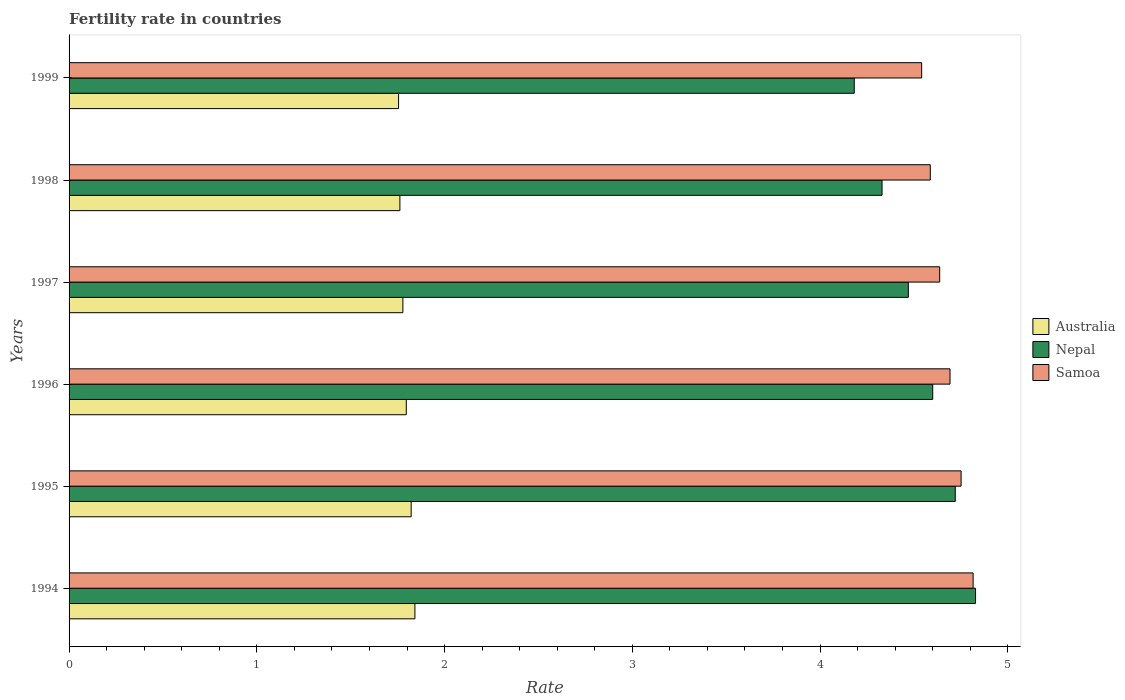How many different coloured bars are there?
Make the answer very short. 3. How many groups of bars are there?
Keep it short and to the point. 6. Are the number of bars per tick equal to the number of legend labels?
Make the answer very short. Yes. In how many cases, is the number of bars for a given year not equal to the number of legend labels?
Your response must be concise. 0. What is the fertility rate in Nepal in 1999?
Give a very brief answer. 4.18. Across all years, what is the maximum fertility rate in Samoa?
Offer a very short reply. 4.82. Across all years, what is the minimum fertility rate in Samoa?
Offer a very short reply. 4.54. What is the total fertility rate in Australia in the graph?
Your response must be concise. 10.75. What is the difference between the fertility rate in Samoa in 1994 and that in 1997?
Your answer should be very brief. 0.18. What is the difference between the fertility rate in Australia in 1994 and the fertility rate in Samoa in 1997?
Your answer should be very brief. -2.79. What is the average fertility rate in Australia per year?
Make the answer very short. 1.79. In the year 1995, what is the difference between the fertility rate in Nepal and fertility rate in Australia?
Offer a very short reply. 2.9. In how many years, is the fertility rate in Australia greater than 4 ?
Give a very brief answer. 0. What is the ratio of the fertility rate in Nepal in 1994 to that in 1998?
Make the answer very short. 1.12. Is the fertility rate in Australia in 1996 less than that in 1999?
Your response must be concise. No. What is the difference between the highest and the second highest fertility rate in Australia?
Provide a succinct answer. 0.02. What is the difference between the highest and the lowest fertility rate in Nepal?
Your answer should be compact. 0.65. In how many years, is the fertility rate in Samoa greater than the average fertility rate in Samoa taken over all years?
Keep it short and to the point. 3. Is the sum of the fertility rate in Australia in 1995 and 1997 greater than the maximum fertility rate in Samoa across all years?
Offer a very short reply. No. What does the 2nd bar from the top in 1999 represents?
Provide a short and direct response. Nepal. What does the 3rd bar from the bottom in 1994 represents?
Offer a very short reply. Samoa. Is it the case that in every year, the sum of the fertility rate in Samoa and fertility rate in Australia is greater than the fertility rate in Nepal?
Offer a terse response. Yes. How many years are there in the graph?
Provide a succinct answer. 6. Are the values on the major ticks of X-axis written in scientific E-notation?
Provide a short and direct response. No. Where does the legend appear in the graph?
Your answer should be very brief. Center right. How are the legend labels stacked?
Ensure brevity in your answer.  Vertical. What is the title of the graph?
Provide a short and direct response. Fertility rate in countries. Does "Lao PDR" appear as one of the legend labels in the graph?
Your answer should be very brief. No. What is the label or title of the X-axis?
Provide a short and direct response. Rate. What is the Rate of Australia in 1994?
Your answer should be very brief. 1.84. What is the Rate in Nepal in 1994?
Your answer should be compact. 4.83. What is the Rate in Samoa in 1994?
Make the answer very short. 4.82. What is the Rate of Australia in 1995?
Your response must be concise. 1.82. What is the Rate in Nepal in 1995?
Your answer should be very brief. 4.72. What is the Rate in Samoa in 1995?
Your answer should be compact. 4.75. What is the Rate of Australia in 1996?
Your response must be concise. 1.8. What is the Rate of Samoa in 1996?
Ensure brevity in your answer.  4.69. What is the Rate in Australia in 1997?
Offer a terse response. 1.78. What is the Rate of Nepal in 1997?
Your answer should be very brief. 4.47. What is the Rate of Samoa in 1997?
Offer a very short reply. 4.64. What is the Rate of Australia in 1998?
Give a very brief answer. 1.76. What is the Rate in Nepal in 1998?
Provide a succinct answer. 4.33. What is the Rate in Samoa in 1998?
Ensure brevity in your answer.  4.59. What is the Rate in Australia in 1999?
Make the answer very short. 1.75. What is the Rate of Nepal in 1999?
Provide a succinct answer. 4.18. What is the Rate in Samoa in 1999?
Your response must be concise. 4.54. Across all years, what is the maximum Rate of Australia?
Make the answer very short. 1.84. Across all years, what is the maximum Rate of Nepal?
Keep it short and to the point. 4.83. Across all years, what is the maximum Rate of Samoa?
Keep it short and to the point. 4.82. Across all years, what is the minimum Rate of Australia?
Make the answer very short. 1.75. Across all years, what is the minimum Rate in Nepal?
Give a very brief answer. 4.18. Across all years, what is the minimum Rate of Samoa?
Ensure brevity in your answer.  4.54. What is the total Rate of Australia in the graph?
Keep it short and to the point. 10.76. What is the total Rate of Nepal in the graph?
Provide a short and direct response. 27.13. What is the total Rate of Samoa in the graph?
Provide a short and direct response. 28.02. What is the difference between the Rate of Nepal in 1994 and that in 1995?
Provide a succinct answer. 0.11. What is the difference between the Rate in Samoa in 1994 and that in 1995?
Your answer should be very brief. 0.06. What is the difference between the Rate of Australia in 1994 and that in 1996?
Provide a short and direct response. 0.05. What is the difference between the Rate of Nepal in 1994 and that in 1996?
Provide a succinct answer. 0.23. What is the difference between the Rate in Samoa in 1994 and that in 1996?
Your answer should be very brief. 0.12. What is the difference between the Rate of Australia in 1994 and that in 1997?
Provide a short and direct response. 0.06. What is the difference between the Rate of Nepal in 1994 and that in 1997?
Keep it short and to the point. 0.36. What is the difference between the Rate of Samoa in 1994 and that in 1997?
Provide a succinct answer. 0.18. What is the difference between the Rate in Australia in 1994 and that in 1998?
Make the answer very short. 0.08. What is the difference between the Rate of Nepal in 1994 and that in 1998?
Offer a terse response. 0.5. What is the difference between the Rate of Samoa in 1994 and that in 1998?
Your answer should be compact. 0.23. What is the difference between the Rate in Australia in 1994 and that in 1999?
Ensure brevity in your answer.  0.09. What is the difference between the Rate of Nepal in 1994 and that in 1999?
Your answer should be very brief. 0.65. What is the difference between the Rate of Samoa in 1994 and that in 1999?
Offer a terse response. 0.27. What is the difference between the Rate of Australia in 1995 and that in 1996?
Your response must be concise. 0.03. What is the difference between the Rate in Nepal in 1995 and that in 1996?
Your answer should be compact. 0.12. What is the difference between the Rate in Samoa in 1995 and that in 1996?
Your response must be concise. 0.06. What is the difference between the Rate of Australia in 1995 and that in 1997?
Offer a terse response. 0.04. What is the difference between the Rate in Samoa in 1995 and that in 1997?
Your answer should be very brief. 0.11. What is the difference between the Rate in Australia in 1995 and that in 1998?
Your answer should be compact. 0.06. What is the difference between the Rate in Nepal in 1995 and that in 1998?
Your answer should be very brief. 0.39. What is the difference between the Rate in Samoa in 1995 and that in 1998?
Provide a short and direct response. 0.16. What is the difference between the Rate of Australia in 1995 and that in 1999?
Provide a succinct answer. 0.07. What is the difference between the Rate in Nepal in 1995 and that in 1999?
Your answer should be compact. 0.54. What is the difference between the Rate in Samoa in 1995 and that in 1999?
Provide a short and direct response. 0.21. What is the difference between the Rate in Australia in 1996 and that in 1997?
Provide a short and direct response. 0.02. What is the difference between the Rate in Nepal in 1996 and that in 1997?
Your response must be concise. 0.13. What is the difference between the Rate of Samoa in 1996 and that in 1997?
Your answer should be very brief. 0.06. What is the difference between the Rate in Australia in 1996 and that in 1998?
Your answer should be very brief. 0.03. What is the difference between the Rate in Nepal in 1996 and that in 1998?
Keep it short and to the point. 0.27. What is the difference between the Rate of Samoa in 1996 and that in 1998?
Keep it short and to the point. 0.1. What is the difference between the Rate of Australia in 1996 and that in 1999?
Ensure brevity in your answer.  0.04. What is the difference between the Rate of Nepal in 1996 and that in 1999?
Provide a succinct answer. 0.42. What is the difference between the Rate of Samoa in 1996 and that in 1999?
Ensure brevity in your answer.  0.15. What is the difference between the Rate in Australia in 1997 and that in 1998?
Offer a very short reply. 0.02. What is the difference between the Rate in Nepal in 1997 and that in 1998?
Offer a terse response. 0.14. What is the difference between the Rate in Australia in 1997 and that in 1999?
Give a very brief answer. 0.02. What is the difference between the Rate in Nepal in 1997 and that in 1999?
Offer a terse response. 0.29. What is the difference between the Rate in Samoa in 1997 and that in 1999?
Offer a very short reply. 0.1. What is the difference between the Rate in Australia in 1998 and that in 1999?
Give a very brief answer. 0.01. What is the difference between the Rate of Nepal in 1998 and that in 1999?
Your response must be concise. 0.15. What is the difference between the Rate in Samoa in 1998 and that in 1999?
Your answer should be very brief. 0.05. What is the difference between the Rate of Australia in 1994 and the Rate of Nepal in 1995?
Provide a succinct answer. -2.88. What is the difference between the Rate of Australia in 1994 and the Rate of Samoa in 1995?
Offer a terse response. -2.91. What is the difference between the Rate in Nepal in 1994 and the Rate in Samoa in 1995?
Ensure brevity in your answer.  0.08. What is the difference between the Rate in Australia in 1994 and the Rate in Nepal in 1996?
Your answer should be compact. -2.76. What is the difference between the Rate in Australia in 1994 and the Rate in Samoa in 1996?
Your answer should be very brief. -2.85. What is the difference between the Rate of Nepal in 1994 and the Rate of Samoa in 1996?
Make the answer very short. 0.14. What is the difference between the Rate of Australia in 1994 and the Rate of Nepal in 1997?
Offer a terse response. -2.63. What is the difference between the Rate in Australia in 1994 and the Rate in Samoa in 1997?
Make the answer very short. -2.79. What is the difference between the Rate of Nepal in 1994 and the Rate of Samoa in 1997?
Provide a short and direct response. 0.19. What is the difference between the Rate of Australia in 1994 and the Rate of Nepal in 1998?
Give a very brief answer. -2.49. What is the difference between the Rate in Australia in 1994 and the Rate in Samoa in 1998?
Provide a short and direct response. -2.75. What is the difference between the Rate of Nepal in 1994 and the Rate of Samoa in 1998?
Offer a terse response. 0.24. What is the difference between the Rate of Australia in 1994 and the Rate of Nepal in 1999?
Keep it short and to the point. -2.34. What is the difference between the Rate in Australia in 1994 and the Rate in Samoa in 1999?
Ensure brevity in your answer.  -2.7. What is the difference between the Rate in Nepal in 1994 and the Rate in Samoa in 1999?
Your response must be concise. 0.29. What is the difference between the Rate in Australia in 1995 and the Rate in Nepal in 1996?
Provide a succinct answer. -2.78. What is the difference between the Rate of Australia in 1995 and the Rate of Samoa in 1996?
Your response must be concise. -2.87. What is the difference between the Rate of Nepal in 1995 and the Rate of Samoa in 1996?
Provide a succinct answer. 0.03. What is the difference between the Rate of Australia in 1995 and the Rate of Nepal in 1997?
Offer a very short reply. -2.65. What is the difference between the Rate in Australia in 1995 and the Rate in Samoa in 1997?
Your response must be concise. -2.81. What is the difference between the Rate of Nepal in 1995 and the Rate of Samoa in 1997?
Give a very brief answer. 0.08. What is the difference between the Rate of Australia in 1995 and the Rate of Nepal in 1998?
Provide a succinct answer. -2.51. What is the difference between the Rate in Australia in 1995 and the Rate in Samoa in 1998?
Make the answer very short. -2.77. What is the difference between the Rate of Nepal in 1995 and the Rate of Samoa in 1998?
Give a very brief answer. 0.13. What is the difference between the Rate in Australia in 1995 and the Rate in Nepal in 1999?
Keep it short and to the point. -2.36. What is the difference between the Rate in Australia in 1995 and the Rate in Samoa in 1999?
Offer a terse response. -2.72. What is the difference between the Rate in Nepal in 1995 and the Rate in Samoa in 1999?
Your response must be concise. 0.18. What is the difference between the Rate in Australia in 1996 and the Rate in Nepal in 1997?
Ensure brevity in your answer.  -2.67. What is the difference between the Rate in Australia in 1996 and the Rate in Samoa in 1997?
Offer a terse response. -2.84. What is the difference between the Rate of Nepal in 1996 and the Rate of Samoa in 1997?
Keep it short and to the point. -0.04. What is the difference between the Rate in Australia in 1996 and the Rate in Nepal in 1998?
Ensure brevity in your answer.  -2.53. What is the difference between the Rate in Australia in 1996 and the Rate in Samoa in 1998?
Make the answer very short. -2.79. What is the difference between the Rate of Nepal in 1996 and the Rate of Samoa in 1998?
Provide a succinct answer. 0.01. What is the difference between the Rate in Australia in 1996 and the Rate in Nepal in 1999?
Your answer should be very brief. -2.39. What is the difference between the Rate in Australia in 1996 and the Rate in Samoa in 1999?
Offer a terse response. -2.75. What is the difference between the Rate in Nepal in 1996 and the Rate in Samoa in 1999?
Keep it short and to the point. 0.06. What is the difference between the Rate of Australia in 1997 and the Rate of Nepal in 1998?
Make the answer very short. -2.55. What is the difference between the Rate in Australia in 1997 and the Rate in Samoa in 1998?
Provide a succinct answer. -2.81. What is the difference between the Rate in Nepal in 1997 and the Rate in Samoa in 1998?
Keep it short and to the point. -0.12. What is the difference between the Rate of Australia in 1997 and the Rate of Nepal in 1999?
Your answer should be compact. -2.4. What is the difference between the Rate of Australia in 1997 and the Rate of Samoa in 1999?
Offer a very short reply. -2.76. What is the difference between the Rate in Nepal in 1997 and the Rate in Samoa in 1999?
Provide a short and direct response. -0.07. What is the difference between the Rate of Australia in 1998 and the Rate of Nepal in 1999?
Offer a very short reply. -2.42. What is the difference between the Rate of Australia in 1998 and the Rate of Samoa in 1999?
Make the answer very short. -2.78. What is the difference between the Rate of Nepal in 1998 and the Rate of Samoa in 1999?
Provide a succinct answer. -0.21. What is the average Rate of Australia per year?
Your answer should be compact. 1.79. What is the average Rate of Nepal per year?
Keep it short and to the point. 4.52. What is the average Rate in Samoa per year?
Provide a succinct answer. 4.67. In the year 1994, what is the difference between the Rate of Australia and Rate of Nepal?
Make the answer very short. -2.99. In the year 1994, what is the difference between the Rate of Australia and Rate of Samoa?
Your answer should be very brief. -2.97. In the year 1994, what is the difference between the Rate in Nepal and Rate in Samoa?
Keep it short and to the point. 0.01. In the year 1995, what is the difference between the Rate in Australia and Rate in Nepal?
Provide a short and direct response. -2.9. In the year 1995, what is the difference between the Rate of Australia and Rate of Samoa?
Make the answer very short. -2.93. In the year 1995, what is the difference between the Rate of Nepal and Rate of Samoa?
Your answer should be very brief. -0.03. In the year 1996, what is the difference between the Rate of Australia and Rate of Nepal?
Provide a succinct answer. -2.8. In the year 1996, what is the difference between the Rate in Australia and Rate in Samoa?
Provide a short and direct response. -2.9. In the year 1996, what is the difference between the Rate of Nepal and Rate of Samoa?
Offer a very short reply. -0.09. In the year 1997, what is the difference between the Rate of Australia and Rate of Nepal?
Give a very brief answer. -2.69. In the year 1997, what is the difference between the Rate of Australia and Rate of Samoa?
Your answer should be compact. -2.86. In the year 1997, what is the difference between the Rate in Nepal and Rate in Samoa?
Offer a very short reply. -0.17. In the year 1998, what is the difference between the Rate in Australia and Rate in Nepal?
Give a very brief answer. -2.57. In the year 1998, what is the difference between the Rate of Australia and Rate of Samoa?
Offer a very short reply. -2.83. In the year 1998, what is the difference between the Rate of Nepal and Rate of Samoa?
Ensure brevity in your answer.  -0.26. In the year 1999, what is the difference between the Rate of Australia and Rate of Nepal?
Provide a succinct answer. -2.43. In the year 1999, what is the difference between the Rate in Australia and Rate in Samoa?
Ensure brevity in your answer.  -2.79. In the year 1999, what is the difference between the Rate of Nepal and Rate of Samoa?
Offer a terse response. -0.36. What is the ratio of the Rate of Nepal in 1994 to that in 1995?
Ensure brevity in your answer.  1.02. What is the ratio of the Rate of Samoa in 1994 to that in 1995?
Keep it short and to the point. 1.01. What is the ratio of the Rate in Australia in 1994 to that in 1996?
Offer a terse response. 1.03. What is the ratio of the Rate of Nepal in 1994 to that in 1996?
Make the answer very short. 1.05. What is the ratio of the Rate of Samoa in 1994 to that in 1996?
Make the answer very short. 1.03. What is the ratio of the Rate of Australia in 1994 to that in 1997?
Give a very brief answer. 1.04. What is the ratio of the Rate in Nepal in 1994 to that in 1997?
Provide a succinct answer. 1.08. What is the ratio of the Rate of Samoa in 1994 to that in 1997?
Your response must be concise. 1.04. What is the ratio of the Rate in Australia in 1994 to that in 1998?
Your response must be concise. 1.05. What is the ratio of the Rate of Nepal in 1994 to that in 1998?
Your answer should be compact. 1.11. What is the ratio of the Rate of Samoa in 1994 to that in 1998?
Offer a very short reply. 1.05. What is the ratio of the Rate of Australia in 1994 to that in 1999?
Keep it short and to the point. 1.05. What is the ratio of the Rate of Nepal in 1994 to that in 1999?
Provide a succinct answer. 1.15. What is the ratio of the Rate of Samoa in 1994 to that in 1999?
Keep it short and to the point. 1.06. What is the ratio of the Rate of Australia in 1995 to that in 1996?
Offer a terse response. 1.01. What is the ratio of the Rate of Nepal in 1995 to that in 1996?
Provide a succinct answer. 1.03. What is the ratio of the Rate of Samoa in 1995 to that in 1996?
Offer a very short reply. 1.01. What is the ratio of the Rate of Australia in 1995 to that in 1997?
Offer a terse response. 1.02. What is the ratio of the Rate of Nepal in 1995 to that in 1997?
Give a very brief answer. 1.06. What is the ratio of the Rate of Samoa in 1995 to that in 1997?
Offer a very short reply. 1.02. What is the ratio of the Rate of Australia in 1995 to that in 1998?
Provide a short and direct response. 1.03. What is the ratio of the Rate of Nepal in 1995 to that in 1998?
Ensure brevity in your answer.  1.09. What is the ratio of the Rate of Samoa in 1995 to that in 1998?
Keep it short and to the point. 1.04. What is the ratio of the Rate in Australia in 1995 to that in 1999?
Give a very brief answer. 1.04. What is the ratio of the Rate of Nepal in 1995 to that in 1999?
Your response must be concise. 1.13. What is the ratio of the Rate of Samoa in 1995 to that in 1999?
Your answer should be very brief. 1.05. What is the ratio of the Rate in Australia in 1996 to that in 1997?
Offer a very short reply. 1.01. What is the ratio of the Rate in Nepal in 1996 to that in 1997?
Offer a terse response. 1.03. What is the ratio of the Rate of Samoa in 1996 to that in 1997?
Provide a succinct answer. 1.01. What is the ratio of the Rate in Australia in 1996 to that in 1998?
Provide a succinct answer. 1.02. What is the ratio of the Rate of Nepal in 1996 to that in 1998?
Your response must be concise. 1.06. What is the ratio of the Rate in Samoa in 1996 to that in 1998?
Keep it short and to the point. 1.02. What is the ratio of the Rate in Australia in 1996 to that in 1999?
Your response must be concise. 1.02. What is the ratio of the Rate in Nepal in 1996 to that in 1999?
Your answer should be very brief. 1.1. What is the ratio of the Rate in Samoa in 1996 to that in 1999?
Your answer should be very brief. 1.03. What is the ratio of the Rate in Australia in 1997 to that in 1998?
Provide a succinct answer. 1.01. What is the ratio of the Rate of Nepal in 1997 to that in 1998?
Give a very brief answer. 1.03. What is the ratio of the Rate of Samoa in 1997 to that in 1998?
Offer a very short reply. 1.01. What is the ratio of the Rate in Australia in 1997 to that in 1999?
Provide a succinct answer. 1.01. What is the ratio of the Rate in Nepal in 1997 to that in 1999?
Your response must be concise. 1.07. What is the ratio of the Rate of Samoa in 1997 to that in 1999?
Offer a very short reply. 1.02. What is the ratio of the Rate in Nepal in 1998 to that in 1999?
Your answer should be very brief. 1.04. What is the difference between the highest and the second highest Rate of Nepal?
Ensure brevity in your answer.  0.11. What is the difference between the highest and the second highest Rate in Samoa?
Provide a succinct answer. 0.06. What is the difference between the highest and the lowest Rate of Australia?
Your response must be concise. 0.09. What is the difference between the highest and the lowest Rate in Nepal?
Provide a short and direct response. 0.65. What is the difference between the highest and the lowest Rate in Samoa?
Offer a very short reply. 0.27. 